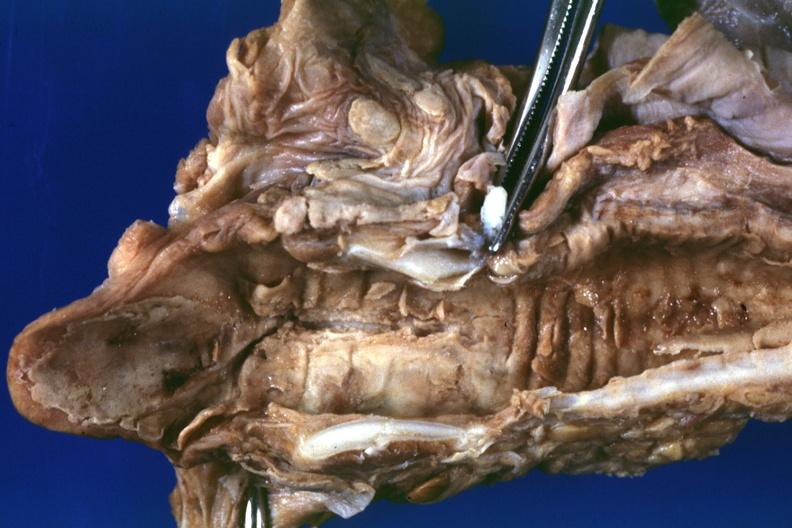what does this image show?
Answer the question using a single word or phrase. Severe necrotizing lesion in mucosa good example also a in file 33 year old female with adenoid cystic carcinoma of trachea a19-88 